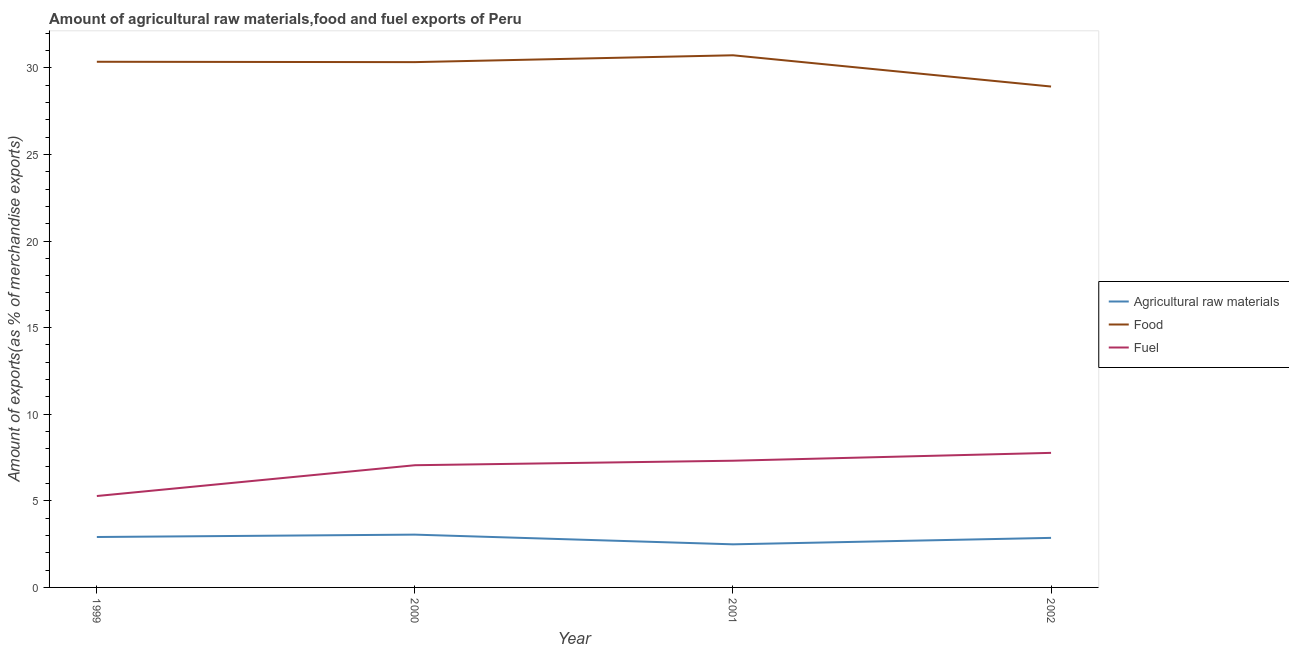Does the line corresponding to percentage of raw materials exports intersect with the line corresponding to percentage of fuel exports?
Give a very brief answer. No. Is the number of lines equal to the number of legend labels?
Give a very brief answer. Yes. What is the percentage of fuel exports in 1999?
Give a very brief answer. 5.28. Across all years, what is the maximum percentage of food exports?
Your answer should be compact. 30.72. Across all years, what is the minimum percentage of raw materials exports?
Make the answer very short. 2.49. What is the total percentage of raw materials exports in the graph?
Provide a short and direct response. 11.31. What is the difference between the percentage of raw materials exports in 2000 and that in 2001?
Your answer should be compact. 0.56. What is the difference between the percentage of raw materials exports in 2001 and the percentage of fuel exports in 2000?
Ensure brevity in your answer.  -4.57. What is the average percentage of food exports per year?
Provide a succinct answer. 30.08. In the year 1999, what is the difference between the percentage of raw materials exports and percentage of food exports?
Provide a succinct answer. -27.44. What is the ratio of the percentage of food exports in 1999 to that in 2000?
Offer a terse response. 1. Is the percentage of raw materials exports in 2000 less than that in 2002?
Ensure brevity in your answer.  No. Is the difference between the percentage of fuel exports in 2000 and 2001 greater than the difference between the percentage of food exports in 2000 and 2001?
Your answer should be compact. Yes. What is the difference between the highest and the second highest percentage of fuel exports?
Your response must be concise. 0.45. What is the difference between the highest and the lowest percentage of raw materials exports?
Provide a short and direct response. 0.56. Is the sum of the percentage of raw materials exports in 2000 and 2002 greater than the maximum percentage of food exports across all years?
Your answer should be very brief. No. Is it the case that in every year, the sum of the percentage of raw materials exports and percentage of food exports is greater than the percentage of fuel exports?
Offer a very short reply. Yes. Does the percentage of raw materials exports monotonically increase over the years?
Offer a terse response. No. How many lines are there?
Provide a short and direct response. 3. How many years are there in the graph?
Provide a short and direct response. 4. What is the difference between two consecutive major ticks on the Y-axis?
Give a very brief answer. 5. Are the values on the major ticks of Y-axis written in scientific E-notation?
Your response must be concise. No. How many legend labels are there?
Make the answer very short. 3. What is the title of the graph?
Provide a succinct answer. Amount of agricultural raw materials,food and fuel exports of Peru. Does "Tertiary education" appear as one of the legend labels in the graph?
Your response must be concise. No. What is the label or title of the Y-axis?
Offer a terse response. Amount of exports(as % of merchandise exports). What is the Amount of exports(as % of merchandise exports) of Agricultural raw materials in 1999?
Your answer should be compact. 2.91. What is the Amount of exports(as % of merchandise exports) of Food in 1999?
Offer a terse response. 30.35. What is the Amount of exports(as % of merchandise exports) of Fuel in 1999?
Make the answer very short. 5.28. What is the Amount of exports(as % of merchandise exports) in Agricultural raw materials in 2000?
Your answer should be compact. 3.05. What is the Amount of exports(as % of merchandise exports) in Food in 2000?
Your answer should be compact. 30.33. What is the Amount of exports(as % of merchandise exports) in Fuel in 2000?
Your answer should be compact. 7.06. What is the Amount of exports(as % of merchandise exports) of Agricultural raw materials in 2001?
Your answer should be compact. 2.49. What is the Amount of exports(as % of merchandise exports) of Food in 2001?
Give a very brief answer. 30.72. What is the Amount of exports(as % of merchandise exports) in Fuel in 2001?
Make the answer very short. 7.32. What is the Amount of exports(as % of merchandise exports) of Agricultural raw materials in 2002?
Your answer should be compact. 2.86. What is the Amount of exports(as % of merchandise exports) of Food in 2002?
Give a very brief answer. 28.92. What is the Amount of exports(as % of merchandise exports) in Fuel in 2002?
Your answer should be compact. 7.77. Across all years, what is the maximum Amount of exports(as % of merchandise exports) of Agricultural raw materials?
Give a very brief answer. 3.05. Across all years, what is the maximum Amount of exports(as % of merchandise exports) of Food?
Offer a very short reply. 30.72. Across all years, what is the maximum Amount of exports(as % of merchandise exports) in Fuel?
Make the answer very short. 7.77. Across all years, what is the minimum Amount of exports(as % of merchandise exports) in Agricultural raw materials?
Give a very brief answer. 2.49. Across all years, what is the minimum Amount of exports(as % of merchandise exports) of Food?
Make the answer very short. 28.92. Across all years, what is the minimum Amount of exports(as % of merchandise exports) in Fuel?
Provide a short and direct response. 5.28. What is the total Amount of exports(as % of merchandise exports) in Agricultural raw materials in the graph?
Your answer should be compact. 11.31. What is the total Amount of exports(as % of merchandise exports) in Food in the graph?
Your answer should be compact. 120.32. What is the total Amount of exports(as % of merchandise exports) in Fuel in the graph?
Provide a succinct answer. 27.42. What is the difference between the Amount of exports(as % of merchandise exports) in Agricultural raw materials in 1999 and that in 2000?
Provide a succinct answer. -0.14. What is the difference between the Amount of exports(as % of merchandise exports) in Food in 1999 and that in 2000?
Keep it short and to the point. 0.02. What is the difference between the Amount of exports(as % of merchandise exports) of Fuel in 1999 and that in 2000?
Offer a terse response. -1.78. What is the difference between the Amount of exports(as % of merchandise exports) in Agricultural raw materials in 1999 and that in 2001?
Keep it short and to the point. 0.42. What is the difference between the Amount of exports(as % of merchandise exports) of Food in 1999 and that in 2001?
Offer a terse response. -0.37. What is the difference between the Amount of exports(as % of merchandise exports) of Fuel in 1999 and that in 2001?
Offer a very short reply. -2.04. What is the difference between the Amount of exports(as % of merchandise exports) in Agricultural raw materials in 1999 and that in 2002?
Your response must be concise. 0.05. What is the difference between the Amount of exports(as % of merchandise exports) of Food in 1999 and that in 2002?
Ensure brevity in your answer.  1.43. What is the difference between the Amount of exports(as % of merchandise exports) of Fuel in 1999 and that in 2002?
Offer a very short reply. -2.49. What is the difference between the Amount of exports(as % of merchandise exports) in Agricultural raw materials in 2000 and that in 2001?
Your answer should be very brief. 0.56. What is the difference between the Amount of exports(as % of merchandise exports) of Food in 2000 and that in 2001?
Ensure brevity in your answer.  -0.4. What is the difference between the Amount of exports(as % of merchandise exports) of Fuel in 2000 and that in 2001?
Keep it short and to the point. -0.26. What is the difference between the Amount of exports(as % of merchandise exports) in Agricultural raw materials in 2000 and that in 2002?
Your answer should be very brief. 0.19. What is the difference between the Amount of exports(as % of merchandise exports) of Food in 2000 and that in 2002?
Give a very brief answer. 1.41. What is the difference between the Amount of exports(as % of merchandise exports) of Fuel in 2000 and that in 2002?
Provide a succinct answer. -0.71. What is the difference between the Amount of exports(as % of merchandise exports) of Agricultural raw materials in 2001 and that in 2002?
Offer a very short reply. -0.37. What is the difference between the Amount of exports(as % of merchandise exports) in Food in 2001 and that in 2002?
Offer a terse response. 1.8. What is the difference between the Amount of exports(as % of merchandise exports) of Fuel in 2001 and that in 2002?
Provide a short and direct response. -0.45. What is the difference between the Amount of exports(as % of merchandise exports) of Agricultural raw materials in 1999 and the Amount of exports(as % of merchandise exports) of Food in 2000?
Provide a short and direct response. -27.42. What is the difference between the Amount of exports(as % of merchandise exports) of Agricultural raw materials in 1999 and the Amount of exports(as % of merchandise exports) of Fuel in 2000?
Your answer should be compact. -4.14. What is the difference between the Amount of exports(as % of merchandise exports) of Food in 1999 and the Amount of exports(as % of merchandise exports) of Fuel in 2000?
Ensure brevity in your answer.  23.29. What is the difference between the Amount of exports(as % of merchandise exports) in Agricultural raw materials in 1999 and the Amount of exports(as % of merchandise exports) in Food in 2001?
Offer a terse response. -27.81. What is the difference between the Amount of exports(as % of merchandise exports) in Agricultural raw materials in 1999 and the Amount of exports(as % of merchandise exports) in Fuel in 2001?
Offer a terse response. -4.4. What is the difference between the Amount of exports(as % of merchandise exports) of Food in 1999 and the Amount of exports(as % of merchandise exports) of Fuel in 2001?
Ensure brevity in your answer.  23.03. What is the difference between the Amount of exports(as % of merchandise exports) in Agricultural raw materials in 1999 and the Amount of exports(as % of merchandise exports) in Food in 2002?
Provide a short and direct response. -26.01. What is the difference between the Amount of exports(as % of merchandise exports) in Agricultural raw materials in 1999 and the Amount of exports(as % of merchandise exports) in Fuel in 2002?
Offer a terse response. -4.86. What is the difference between the Amount of exports(as % of merchandise exports) of Food in 1999 and the Amount of exports(as % of merchandise exports) of Fuel in 2002?
Offer a terse response. 22.58. What is the difference between the Amount of exports(as % of merchandise exports) in Agricultural raw materials in 2000 and the Amount of exports(as % of merchandise exports) in Food in 2001?
Give a very brief answer. -27.68. What is the difference between the Amount of exports(as % of merchandise exports) of Agricultural raw materials in 2000 and the Amount of exports(as % of merchandise exports) of Fuel in 2001?
Your answer should be compact. -4.27. What is the difference between the Amount of exports(as % of merchandise exports) of Food in 2000 and the Amount of exports(as % of merchandise exports) of Fuel in 2001?
Your answer should be very brief. 23.01. What is the difference between the Amount of exports(as % of merchandise exports) in Agricultural raw materials in 2000 and the Amount of exports(as % of merchandise exports) in Food in 2002?
Your response must be concise. -25.87. What is the difference between the Amount of exports(as % of merchandise exports) in Agricultural raw materials in 2000 and the Amount of exports(as % of merchandise exports) in Fuel in 2002?
Provide a short and direct response. -4.72. What is the difference between the Amount of exports(as % of merchandise exports) of Food in 2000 and the Amount of exports(as % of merchandise exports) of Fuel in 2002?
Provide a succinct answer. 22.56. What is the difference between the Amount of exports(as % of merchandise exports) in Agricultural raw materials in 2001 and the Amount of exports(as % of merchandise exports) in Food in 2002?
Offer a very short reply. -26.43. What is the difference between the Amount of exports(as % of merchandise exports) of Agricultural raw materials in 2001 and the Amount of exports(as % of merchandise exports) of Fuel in 2002?
Provide a short and direct response. -5.28. What is the difference between the Amount of exports(as % of merchandise exports) in Food in 2001 and the Amount of exports(as % of merchandise exports) in Fuel in 2002?
Offer a terse response. 22.95. What is the average Amount of exports(as % of merchandise exports) in Agricultural raw materials per year?
Your answer should be very brief. 2.83. What is the average Amount of exports(as % of merchandise exports) of Food per year?
Your answer should be very brief. 30.08. What is the average Amount of exports(as % of merchandise exports) of Fuel per year?
Your answer should be compact. 6.85. In the year 1999, what is the difference between the Amount of exports(as % of merchandise exports) of Agricultural raw materials and Amount of exports(as % of merchandise exports) of Food?
Give a very brief answer. -27.44. In the year 1999, what is the difference between the Amount of exports(as % of merchandise exports) in Agricultural raw materials and Amount of exports(as % of merchandise exports) in Fuel?
Offer a terse response. -2.37. In the year 1999, what is the difference between the Amount of exports(as % of merchandise exports) in Food and Amount of exports(as % of merchandise exports) in Fuel?
Offer a very short reply. 25.07. In the year 2000, what is the difference between the Amount of exports(as % of merchandise exports) of Agricultural raw materials and Amount of exports(as % of merchandise exports) of Food?
Offer a terse response. -27.28. In the year 2000, what is the difference between the Amount of exports(as % of merchandise exports) in Agricultural raw materials and Amount of exports(as % of merchandise exports) in Fuel?
Ensure brevity in your answer.  -4.01. In the year 2000, what is the difference between the Amount of exports(as % of merchandise exports) of Food and Amount of exports(as % of merchandise exports) of Fuel?
Give a very brief answer. 23.27. In the year 2001, what is the difference between the Amount of exports(as % of merchandise exports) in Agricultural raw materials and Amount of exports(as % of merchandise exports) in Food?
Make the answer very short. -28.24. In the year 2001, what is the difference between the Amount of exports(as % of merchandise exports) in Agricultural raw materials and Amount of exports(as % of merchandise exports) in Fuel?
Ensure brevity in your answer.  -4.83. In the year 2001, what is the difference between the Amount of exports(as % of merchandise exports) in Food and Amount of exports(as % of merchandise exports) in Fuel?
Offer a very short reply. 23.41. In the year 2002, what is the difference between the Amount of exports(as % of merchandise exports) of Agricultural raw materials and Amount of exports(as % of merchandise exports) of Food?
Provide a short and direct response. -26.06. In the year 2002, what is the difference between the Amount of exports(as % of merchandise exports) in Agricultural raw materials and Amount of exports(as % of merchandise exports) in Fuel?
Your response must be concise. -4.91. In the year 2002, what is the difference between the Amount of exports(as % of merchandise exports) of Food and Amount of exports(as % of merchandise exports) of Fuel?
Offer a very short reply. 21.15. What is the ratio of the Amount of exports(as % of merchandise exports) of Agricultural raw materials in 1999 to that in 2000?
Your answer should be very brief. 0.96. What is the ratio of the Amount of exports(as % of merchandise exports) of Food in 1999 to that in 2000?
Make the answer very short. 1. What is the ratio of the Amount of exports(as % of merchandise exports) of Fuel in 1999 to that in 2000?
Your response must be concise. 0.75. What is the ratio of the Amount of exports(as % of merchandise exports) of Agricultural raw materials in 1999 to that in 2001?
Provide a succinct answer. 1.17. What is the ratio of the Amount of exports(as % of merchandise exports) in Fuel in 1999 to that in 2001?
Offer a very short reply. 0.72. What is the ratio of the Amount of exports(as % of merchandise exports) in Agricultural raw materials in 1999 to that in 2002?
Your answer should be very brief. 1.02. What is the ratio of the Amount of exports(as % of merchandise exports) in Food in 1999 to that in 2002?
Offer a very short reply. 1.05. What is the ratio of the Amount of exports(as % of merchandise exports) in Fuel in 1999 to that in 2002?
Your response must be concise. 0.68. What is the ratio of the Amount of exports(as % of merchandise exports) of Agricultural raw materials in 2000 to that in 2001?
Your answer should be compact. 1.23. What is the ratio of the Amount of exports(as % of merchandise exports) of Food in 2000 to that in 2001?
Ensure brevity in your answer.  0.99. What is the ratio of the Amount of exports(as % of merchandise exports) of Fuel in 2000 to that in 2001?
Offer a very short reply. 0.96. What is the ratio of the Amount of exports(as % of merchandise exports) of Agricultural raw materials in 2000 to that in 2002?
Offer a terse response. 1.07. What is the ratio of the Amount of exports(as % of merchandise exports) in Food in 2000 to that in 2002?
Give a very brief answer. 1.05. What is the ratio of the Amount of exports(as % of merchandise exports) in Fuel in 2000 to that in 2002?
Ensure brevity in your answer.  0.91. What is the ratio of the Amount of exports(as % of merchandise exports) of Agricultural raw materials in 2001 to that in 2002?
Make the answer very short. 0.87. What is the ratio of the Amount of exports(as % of merchandise exports) in Food in 2001 to that in 2002?
Provide a succinct answer. 1.06. What is the ratio of the Amount of exports(as % of merchandise exports) of Fuel in 2001 to that in 2002?
Make the answer very short. 0.94. What is the difference between the highest and the second highest Amount of exports(as % of merchandise exports) in Agricultural raw materials?
Offer a terse response. 0.14. What is the difference between the highest and the second highest Amount of exports(as % of merchandise exports) of Food?
Make the answer very short. 0.37. What is the difference between the highest and the second highest Amount of exports(as % of merchandise exports) in Fuel?
Keep it short and to the point. 0.45. What is the difference between the highest and the lowest Amount of exports(as % of merchandise exports) in Agricultural raw materials?
Ensure brevity in your answer.  0.56. What is the difference between the highest and the lowest Amount of exports(as % of merchandise exports) of Food?
Keep it short and to the point. 1.8. What is the difference between the highest and the lowest Amount of exports(as % of merchandise exports) of Fuel?
Your response must be concise. 2.49. 